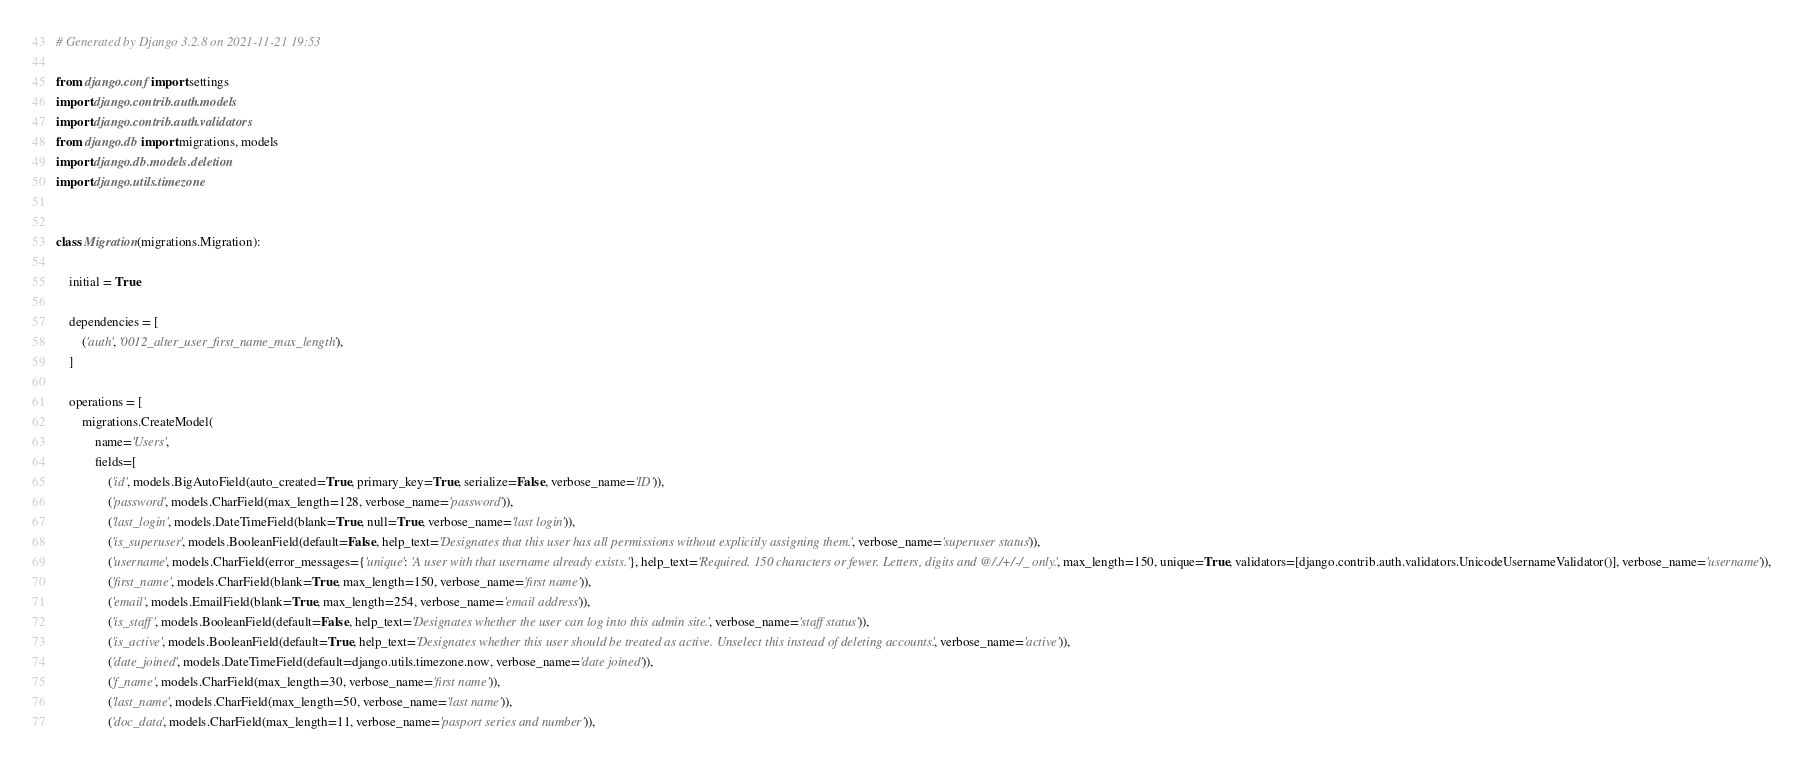Convert code to text. <code><loc_0><loc_0><loc_500><loc_500><_Python_># Generated by Django 3.2.8 on 2021-11-21 19:53

from django.conf import settings
import django.contrib.auth.models
import django.contrib.auth.validators
from django.db import migrations, models
import django.db.models.deletion
import django.utils.timezone


class Migration(migrations.Migration):

    initial = True

    dependencies = [
        ('auth', '0012_alter_user_first_name_max_length'),
    ]

    operations = [
        migrations.CreateModel(
            name='Users',
            fields=[
                ('id', models.BigAutoField(auto_created=True, primary_key=True, serialize=False, verbose_name='ID')),
                ('password', models.CharField(max_length=128, verbose_name='password')),
                ('last_login', models.DateTimeField(blank=True, null=True, verbose_name='last login')),
                ('is_superuser', models.BooleanField(default=False, help_text='Designates that this user has all permissions without explicitly assigning them.', verbose_name='superuser status')),
                ('username', models.CharField(error_messages={'unique': 'A user with that username already exists.'}, help_text='Required. 150 characters or fewer. Letters, digits and @/./+/-/_ only.', max_length=150, unique=True, validators=[django.contrib.auth.validators.UnicodeUsernameValidator()], verbose_name='username')),
                ('first_name', models.CharField(blank=True, max_length=150, verbose_name='first name')),
                ('email', models.EmailField(blank=True, max_length=254, verbose_name='email address')),
                ('is_staff', models.BooleanField(default=False, help_text='Designates whether the user can log into this admin site.', verbose_name='staff status')),
                ('is_active', models.BooleanField(default=True, help_text='Designates whether this user should be treated as active. Unselect this instead of deleting accounts.', verbose_name='active')),
                ('date_joined', models.DateTimeField(default=django.utils.timezone.now, verbose_name='date joined')),
                ('f_name', models.CharField(max_length=30, verbose_name='first name')),
                ('last_name', models.CharField(max_length=50, verbose_name='last name')),
                ('doc_data', models.CharField(max_length=11, verbose_name='pasport series and number ')),</code> 